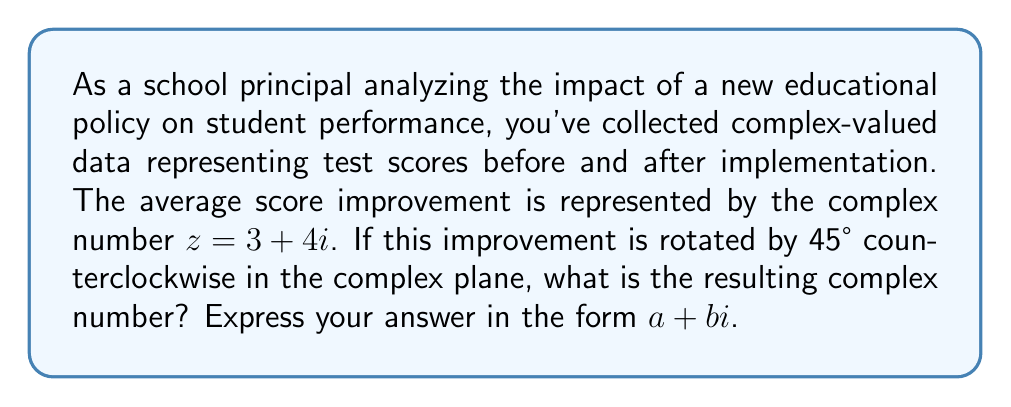Help me with this question. To solve this problem, we'll follow these steps:

1) The rotation of a complex number by an angle θ can be achieved by multiplying the complex number by $e^{iθ}$.

2) In this case, θ = 45° = π/4 radians.

3) We need to calculate $z * e^{iπ/4}$, where $z = 3 + 4i$.

4) $e^{iπ/4}$ can be expressed as $\cos(π/4) + i\sin(π/4)$.

5) We know that $\cos(π/4) = \sin(π/4) = \frac{1}{\sqrt{2}}$.

6) So, $e^{iπ/4} = \frac{1}{\sqrt{2}} + \frac{i}{\sqrt{2}}$.

7) Now, we multiply $z$ by $e^{iπ/4}$:

   $$(3 + 4i) * (\frac{1}{\sqrt{2}} + \frac{i}{\sqrt{2}})$$

8) Expanding this:

   $$\frac{3}{\sqrt{2}} + \frac{3i}{\sqrt{2}} + \frac{4i}{\sqrt{2}} - \frac{4}{\sqrt{2}}$$

9) Combining like terms:

   $$\frac{3-4}{\sqrt{2}} + \frac{3+4}{\sqrt{2}}i$$

   $$\frac{-1}{\sqrt{2}} + \frac{7}{\sqrt{2}}i$$

10) Simplifying:

    $$-\frac{1}{\sqrt{2}} + \frac{7}{\sqrt{2}}i$$

11) To express this in the form $a + bi$, we can rationalize the denominator:

    $$(-\frac{1}{\sqrt{2}} + \frac{7}{\sqrt{2}}i) * \frac{\sqrt{2}}{\sqrt{2}}$$

    $$= -1 + 7i$$

Therefore, the resulting complex number after rotation is $-1 + 7i$.
Answer: $-1 + 7i$ 